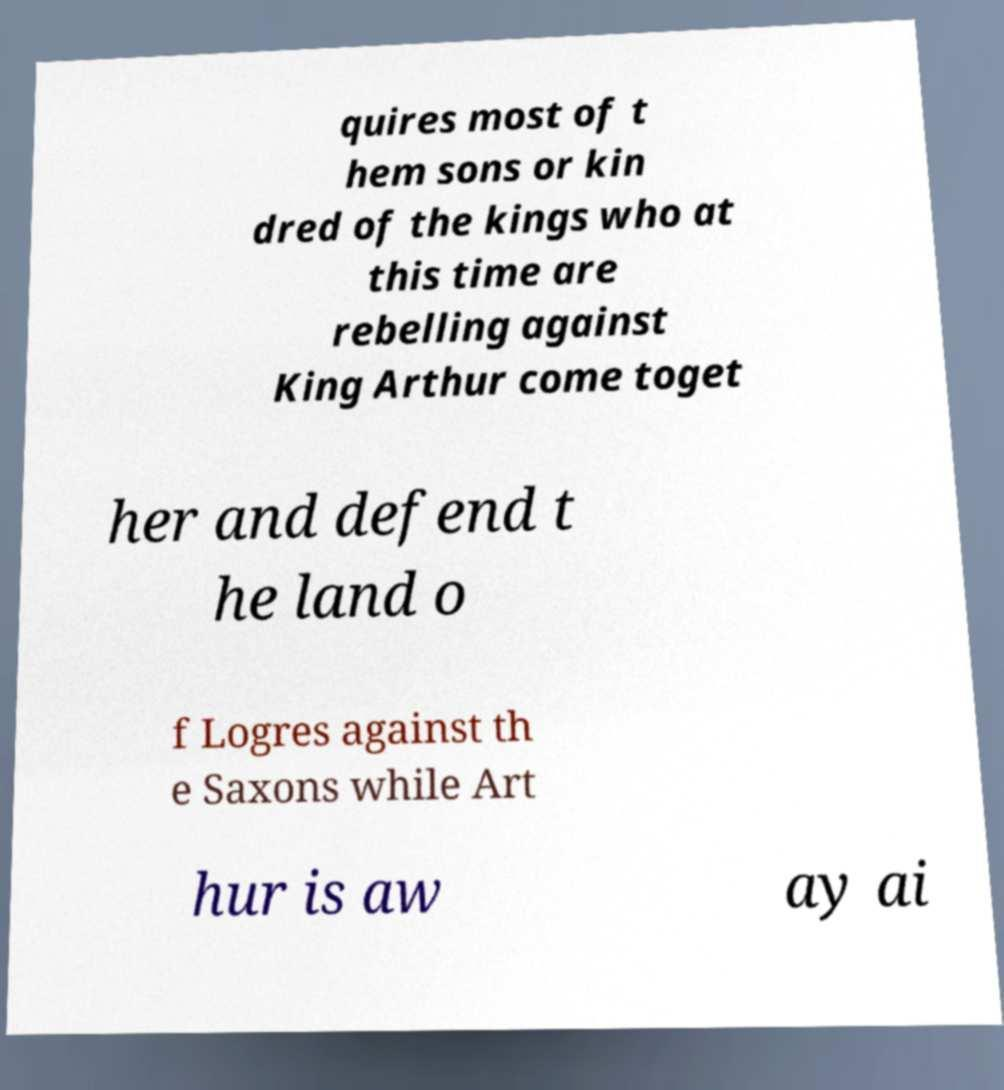I need the written content from this picture converted into text. Can you do that? quires most of t hem sons or kin dred of the kings who at this time are rebelling against King Arthur come toget her and defend t he land o f Logres against th e Saxons while Art hur is aw ay ai 